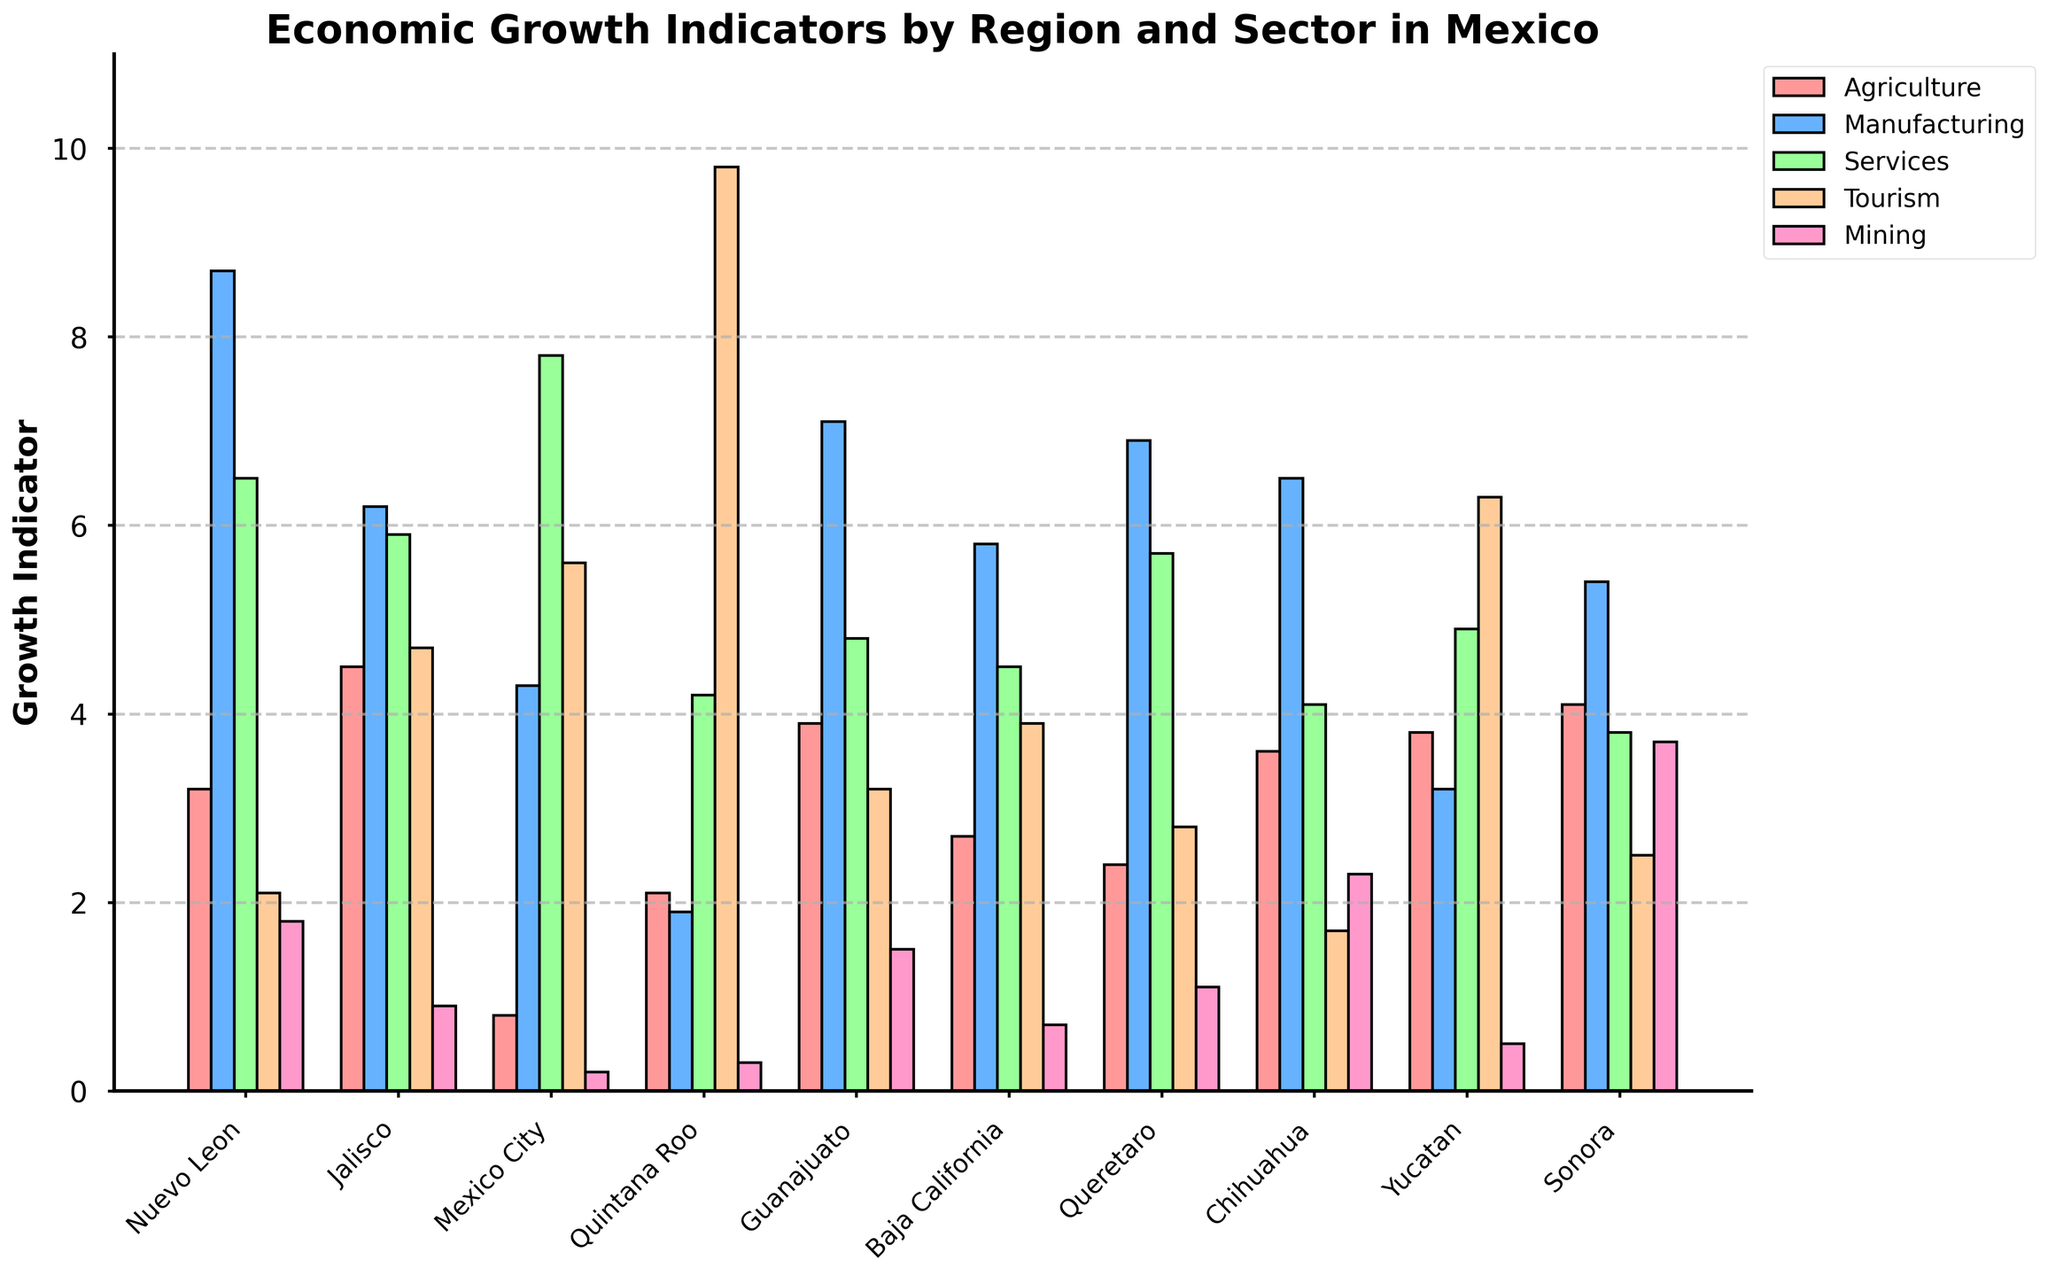Which region has the highest growth indicator in the Tourism sector? Look for the highest bar in the Tourism sector section, which is colored distinctly among the bars. Quintana Roo has the highest Tourism growth indicator of 9.8.
Answer: Quintana Roo Which sector shows the lowest growth indicator for Mexico City, and what is its value? Identify the shortest bar for Mexico City. Mining is the shortest with a value of 0.2.
Answer: Mining, 0.2 Compare the growth indicators for Agriculture between Nuevo Leon and Jalisco. Which one is higher and by how much? Compare the Agriculture bar heights for Nuevo Leon and Jalisco. Jalisco (4.5) is higher than Nuevo Leon (3.2) by 1.3.
Answer: Jalisco, 1.3 What is the average growth indicator of Services across all regions? Add up the Services indicators for all regions and divide by the number of regions. (6.5+5.9+7.8+4.2+4.8+4.5+5.7+4.1+4.9+3.8) / 10 = 5.22
Answer: 5.22 For which sector does Guanajuato show the second highest growth indicator, and what is its value? Identify the second tallest bar for Guanajuato's sectors. The second highest is Manufacturing with a value of 7.1.
Answer: Manufacturing, 7.1 Which region shows the highest growth indicator in Mining, and what is the value? Look for the tallest bar in the Mining section. Sonora has the highest growth indicator in Mining with a value of 3.7.
Answer: Sonora, 3.7 How does the growth indicator of Manufacturing in Baja California compare to that in Queretaro? Compare the Manufacturing bar heights for Baja California and Queretaro. Baja California (5.8) is lower than Queretaro (6.9) by 1.1.
Answer: Queretaro is higher by 1.1 Which region has the lowest overall average growth indicator across all sectors, and what is this average value? Calculate the average growth indicator for all sectors for each region and compare them. Mexico City has the lowest average: (0.8+4.3+7.8+5.6+0.2) / 5 = 3.54
Answer: Mexico City, 3.54 